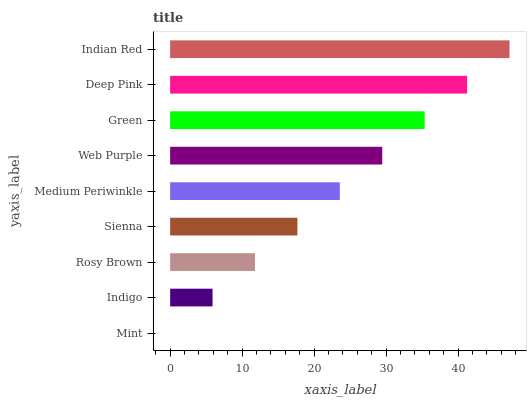Is Mint the minimum?
Answer yes or no. Yes. Is Indian Red the maximum?
Answer yes or no. Yes. Is Indigo the minimum?
Answer yes or no. No. Is Indigo the maximum?
Answer yes or no. No. Is Indigo greater than Mint?
Answer yes or no. Yes. Is Mint less than Indigo?
Answer yes or no. Yes. Is Mint greater than Indigo?
Answer yes or no. No. Is Indigo less than Mint?
Answer yes or no. No. Is Medium Periwinkle the high median?
Answer yes or no. Yes. Is Medium Periwinkle the low median?
Answer yes or no. Yes. Is Rosy Brown the high median?
Answer yes or no. No. Is Deep Pink the low median?
Answer yes or no. No. 